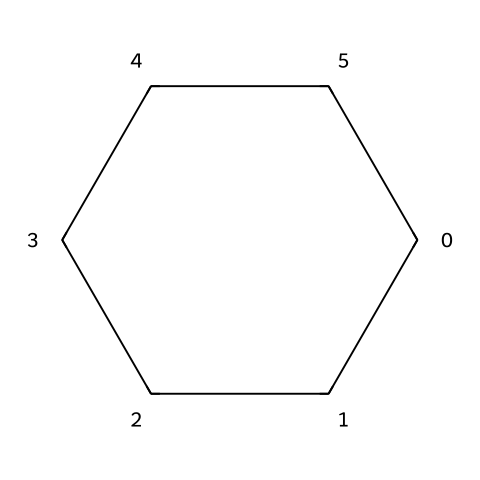What is the name of this chemical structure? The chemical structure represents a cyclic alkane with six carbon atoms. This specific arrangement is known as cyclohexane.
Answer: cyclohexane How many carbon atoms are in the structure? By analyzing the SMILES representation, it is evident that there are six carbon atoms connected in a ring formation.
Answer: six What type of bonds are present in cyclohexane? Cyclohexane consists solely of single bonds between the carbon atoms due to its saturated structure, which is a characteristic of cycloalkanes.
Answer: single bonds Does this structure have any functional groups? Cyclohexane is a saturated hydrocarbon with no functional groups present; its composition only includes carbon and hydrogen atoms in a cyclical arrangement.
Answer: no What is the molecular formula of cyclohexane? By counting the carbon and hydrogen atoms from the structure, the molecular formula can be derived as C6H12, indicating six carbons and twelve hydrogens.
Answer: C6H12 Why is cyclohexane commonly used in dye production? Cyclohexane’s non-polar nature and ability to dissolve various organic compounds make it an excellent solvent in dye production, aiding in the even distribution of color.
Answer: good solvent What type of cycloalkane is represented here? The structure's cyclic formation and the absence of double or triple bonds imply that it is a saturated cycloalkane, making it classified as a cyclohexane.
Answer: saturated cycloalkane 